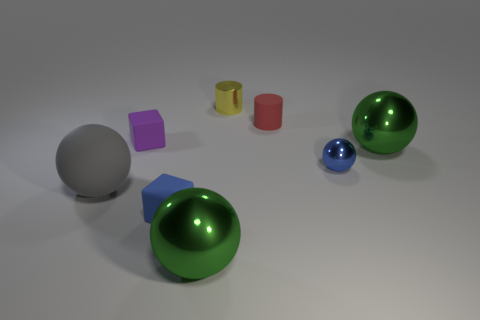Subtract all purple cylinders. How many green spheres are left? 2 Subtract all gray spheres. How many spheres are left? 3 Subtract 2 spheres. How many spheres are left? 2 Subtract all blue balls. How many balls are left? 3 Add 2 large matte balls. How many objects exist? 10 Subtract all yellow spheres. Subtract all purple cubes. How many spheres are left? 4 Subtract all cubes. How many objects are left? 6 Add 1 gray shiny things. How many gray shiny things exist? 1 Subtract 0 cyan balls. How many objects are left? 8 Subtract all large yellow rubber spheres. Subtract all small yellow things. How many objects are left? 7 